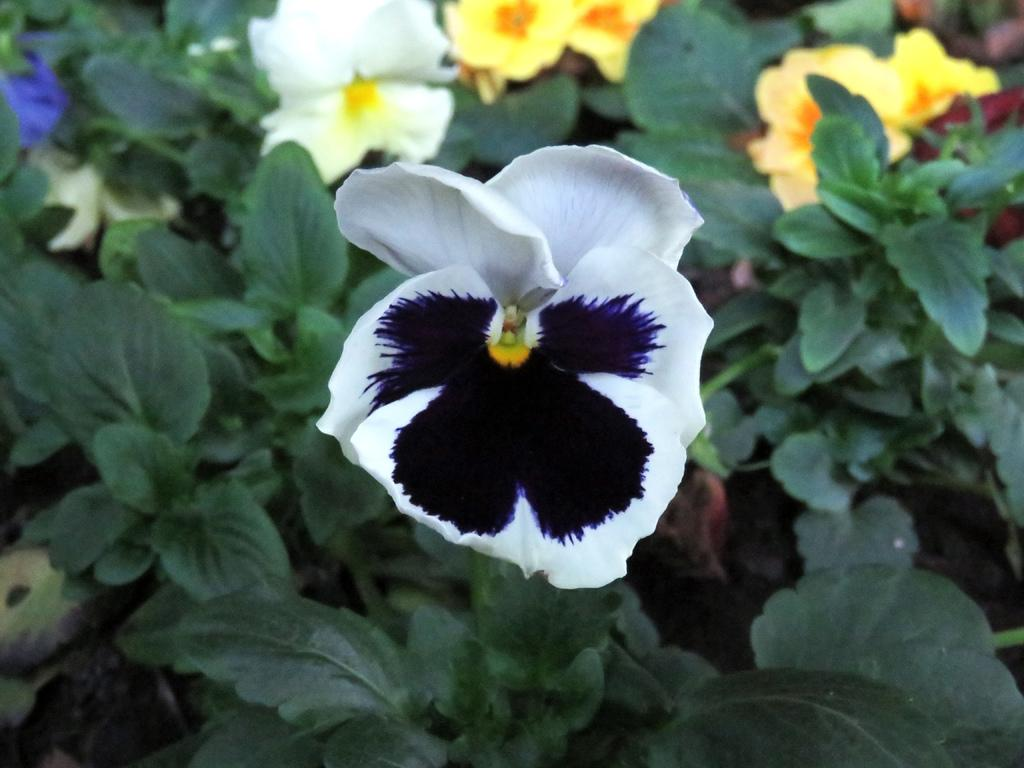What type of living organisms can be seen in the image? Plants can be seen in the image. What features do the plants have? The plants have flowers and leaves. What can be observed about the flowers on the plants? The flowers are of different colors. What brand of toothpaste is being advertised in the image? There is no toothpaste or advertisement present in the image; it features plants with flowers and leaves. 